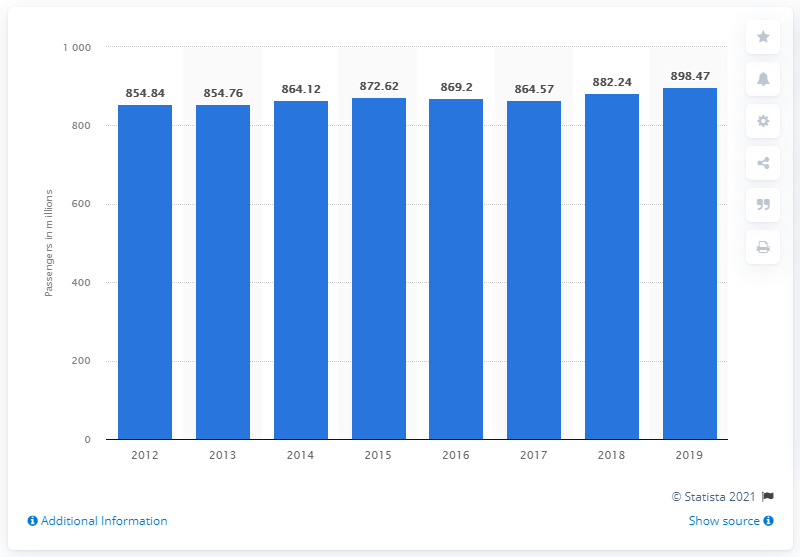Draw attention to some important aspects in this diagram. From 2012 to 2019, the passenger volume in Italy was 898.47 million. 